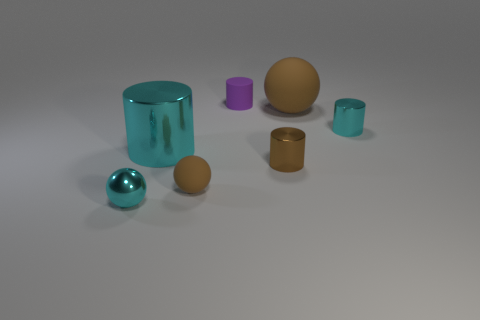What number of large purple matte cylinders are there? There are zero large purple matte cylinders in the image. The objects present include cylinders and spheres but none match the description of being a large purple matte cylinder. 